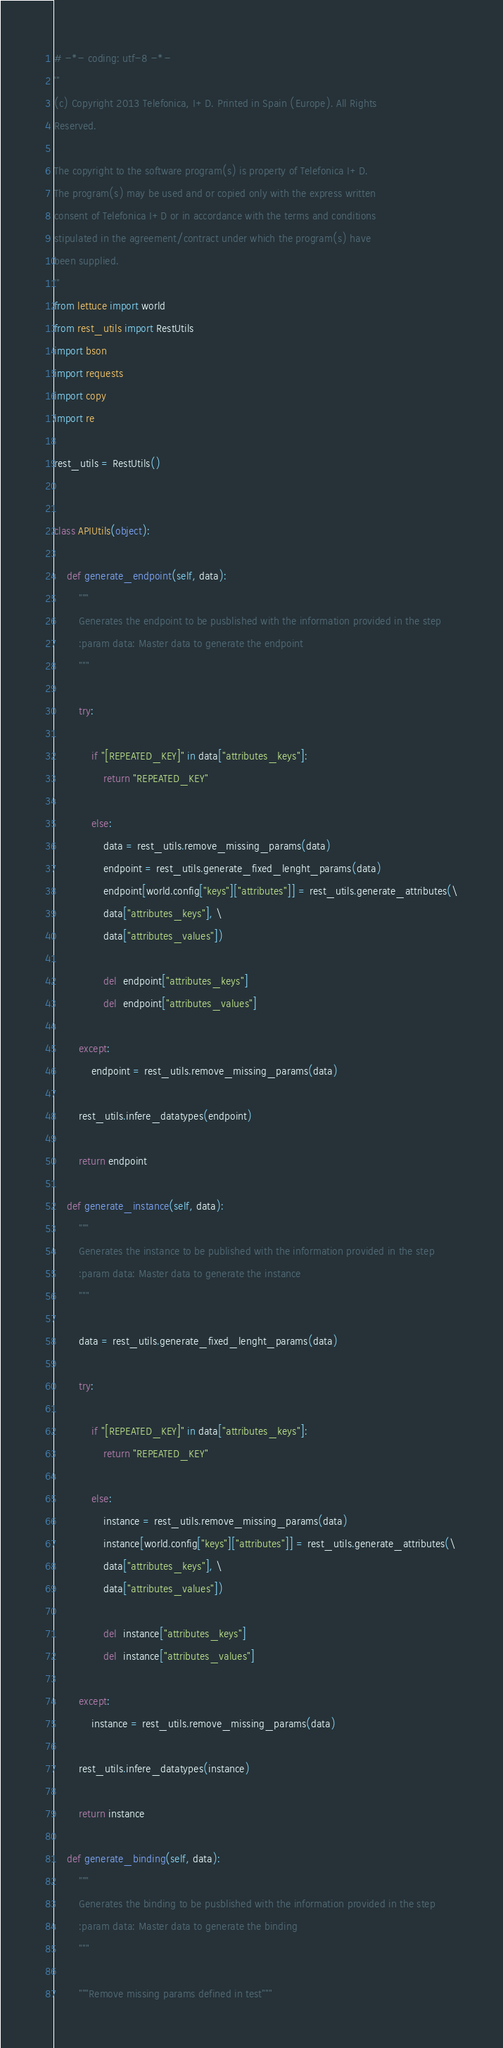Convert code to text. <code><loc_0><loc_0><loc_500><loc_500><_Python_># -*- coding: utf-8 -*-
'''
(c) Copyright 2013 Telefonica, I+D. Printed in Spain (Europe). All Rights
Reserved.

The copyright to the software program(s) is property of Telefonica I+D.
The program(s) may be used and or copied only with the express written
consent of Telefonica I+D or in accordance with the terms and conditions
stipulated in the agreement/contract under which the program(s) have
been supplied.
'''
from lettuce import world
from rest_utils import RestUtils
import bson
import requests
import copy
import re

rest_utils = RestUtils()


class APIUtils(object):

    def generate_endpoint(self, data):
        """
        Generates the endpoint to be pusblished with the information provided in the step
        :param data: Master data to generate the endpoint
        """

        try:

            if "[REPEATED_KEY]" in data["attributes_keys"]:
                return "REPEATED_KEY"

            else:
                data = rest_utils.remove_missing_params(data)
                endpoint = rest_utils.generate_fixed_lenght_params(data)
                endpoint[world.config["keys"]["attributes"]] = rest_utils.generate_attributes(\
                data["attributes_keys"], \
                data["attributes_values"])

                del  endpoint["attributes_keys"]
                del  endpoint["attributes_values"]

        except:
            endpoint = rest_utils.remove_missing_params(data)

        rest_utils.infere_datatypes(endpoint)

        return endpoint

    def generate_instance(self, data):
        """
        Generates the instance to be published with the information provided in the step
        :param data: Master data to generate the instance
        """

        data = rest_utils.generate_fixed_lenght_params(data)

        try:

            if "[REPEATED_KEY]" in data["attributes_keys"]:
                return "REPEATED_KEY"

            else:
                instance = rest_utils.remove_missing_params(data)
                instance[world.config["keys"]["attributes"]] = rest_utils.generate_attributes(\
                data["attributes_keys"], \
                data["attributes_values"])

                del  instance["attributes_keys"]
                del  instance["attributes_values"]

        except:
            instance = rest_utils.remove_missing_params(data)

        rest_utils.infere_datatypes(instance)

        return instance

    def generate_binding(self, data):
        """
        Generates the binding to be pusblished with the information provided in the step
        :param data: Master data to generate the binding
        """

        """Remove missing params defined in test"""</code> 